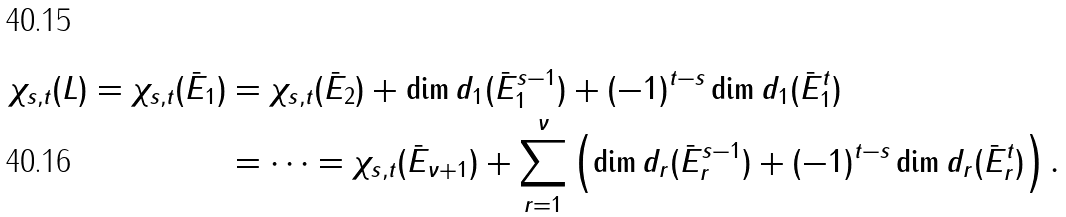Convert formula to latex. <formula><loc_0><loc_0><loc_500><loc_500>\chi _ { s , t } ( L ) = \chi _ { s , t } ( \bar { E } _ { 1 } ) & = \chi _ { s , t } ( \bar { E } _ { 2 } ) + \dim d _ { 1 } ( \bar { E } _ { 1 } ^ { s - 1 } ) + ( - 1 ) ^ { t - s } \dim d _ { 1 } ( \bar { E } _ { 1 } ^ { t } ) \\ & = \dots = \chi _ { s , t } ( \bar { E } _ { \nu + 1 } ) + \sum _ { r = 1 } ^ { \nu } \left ( \dim d _ { r } ( \bar { E } _ { r } ^ { s - 1 } ) + ( - 1 ) ^ { t - s } \dim d _ { r } ( \bar { E } _ { r } ^ { t } ) \right ) .</formula> 